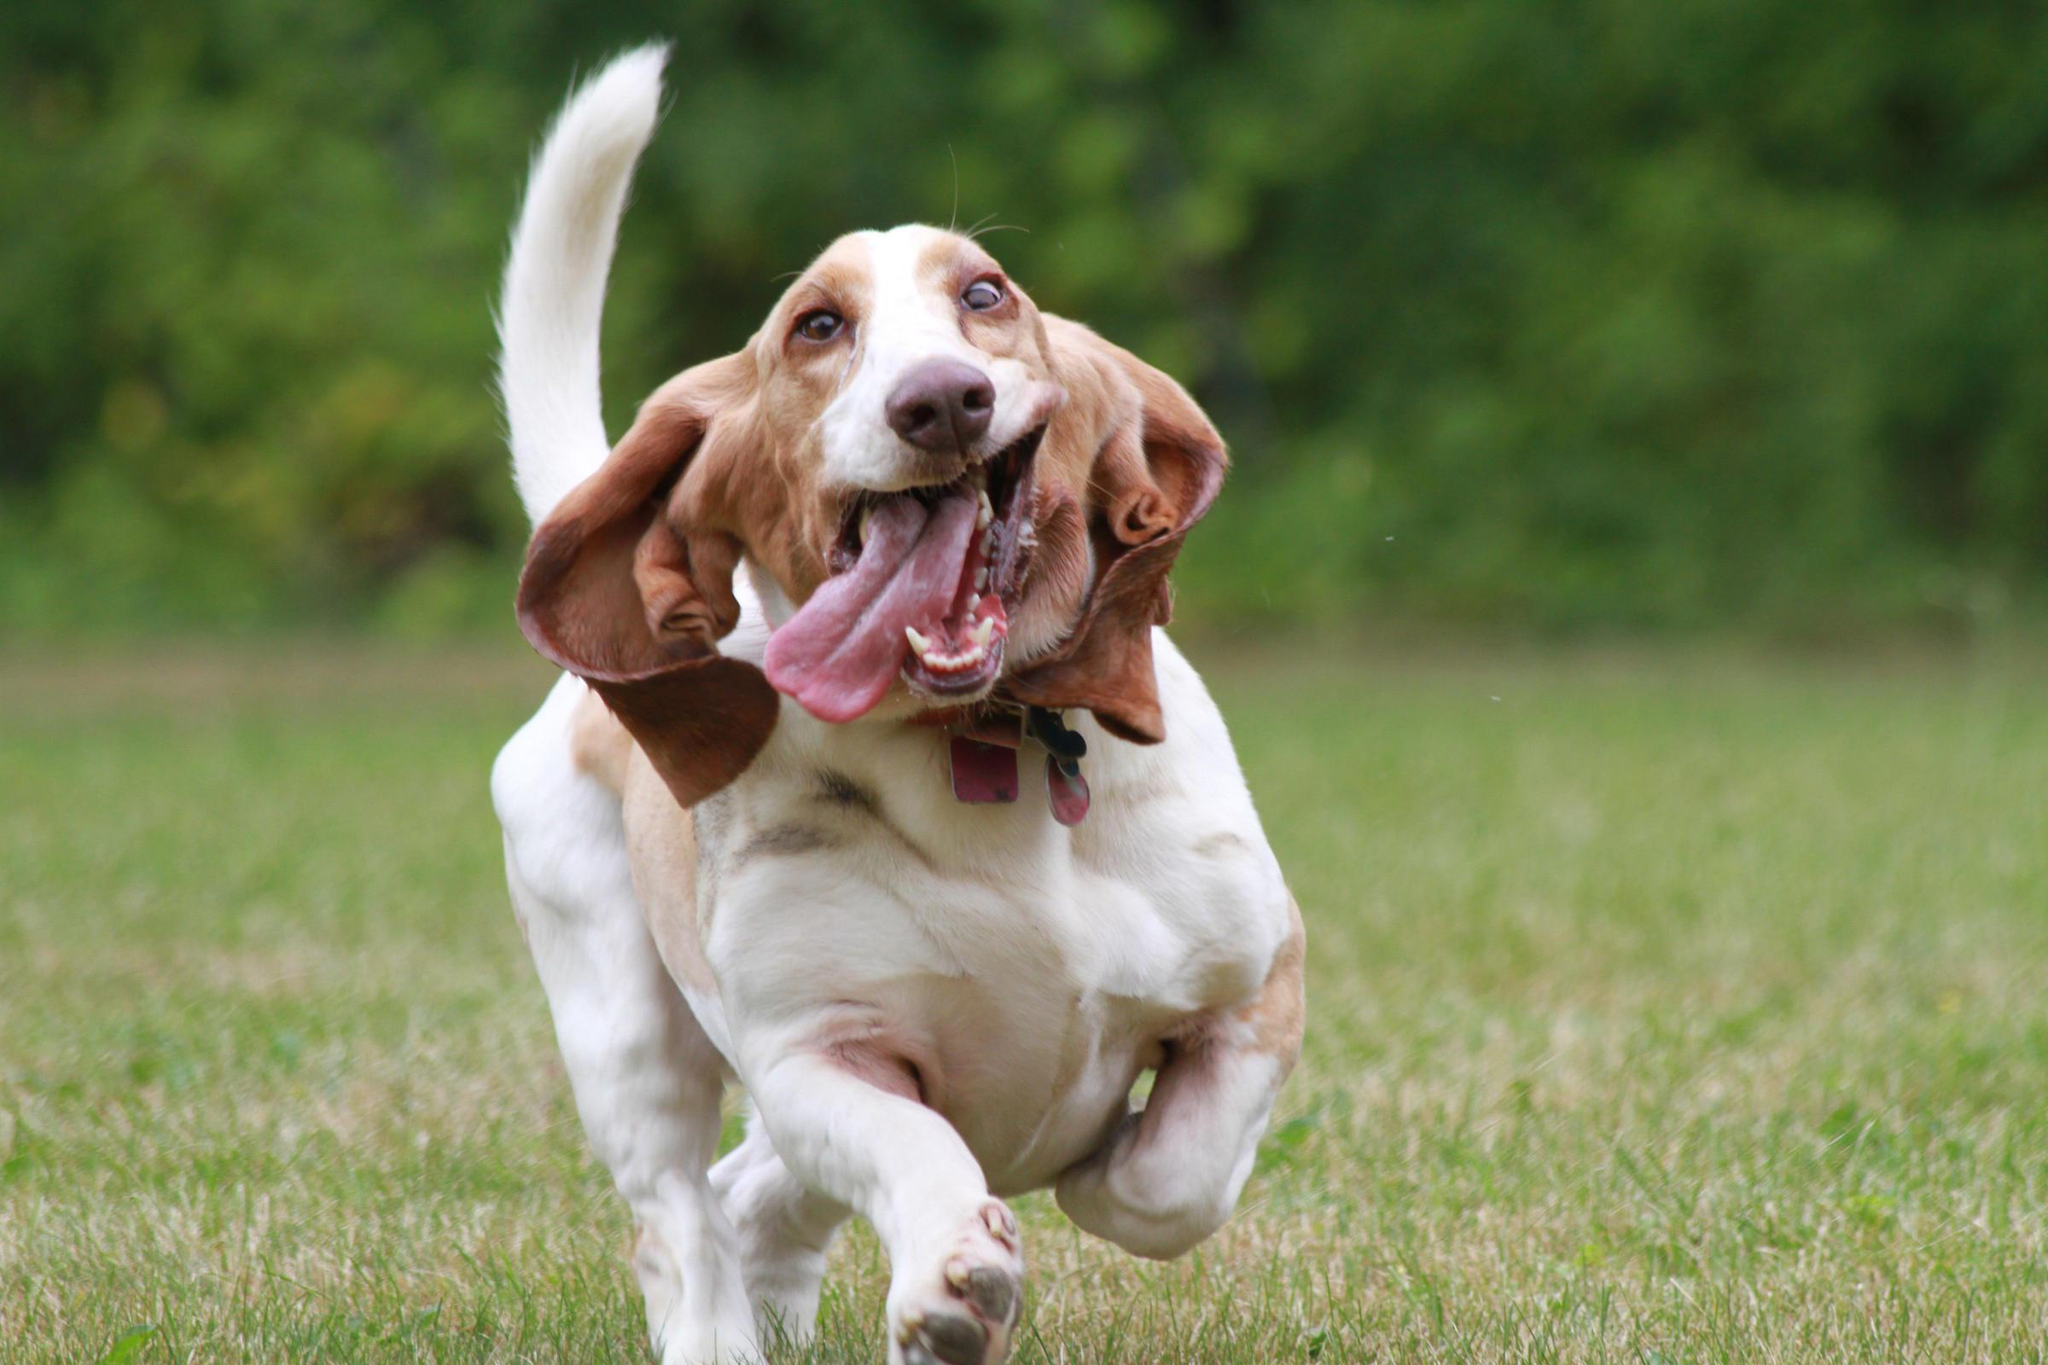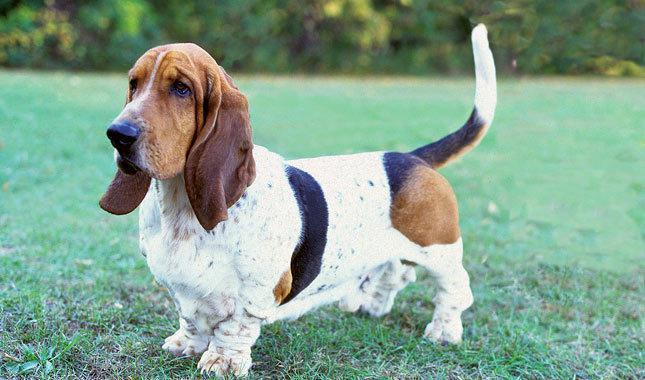The first image is the image on the left, the second image is the image on the right. For the images displayed, is the sentence "There are two dogs" factually correct? Answer yes or no. Yes. 